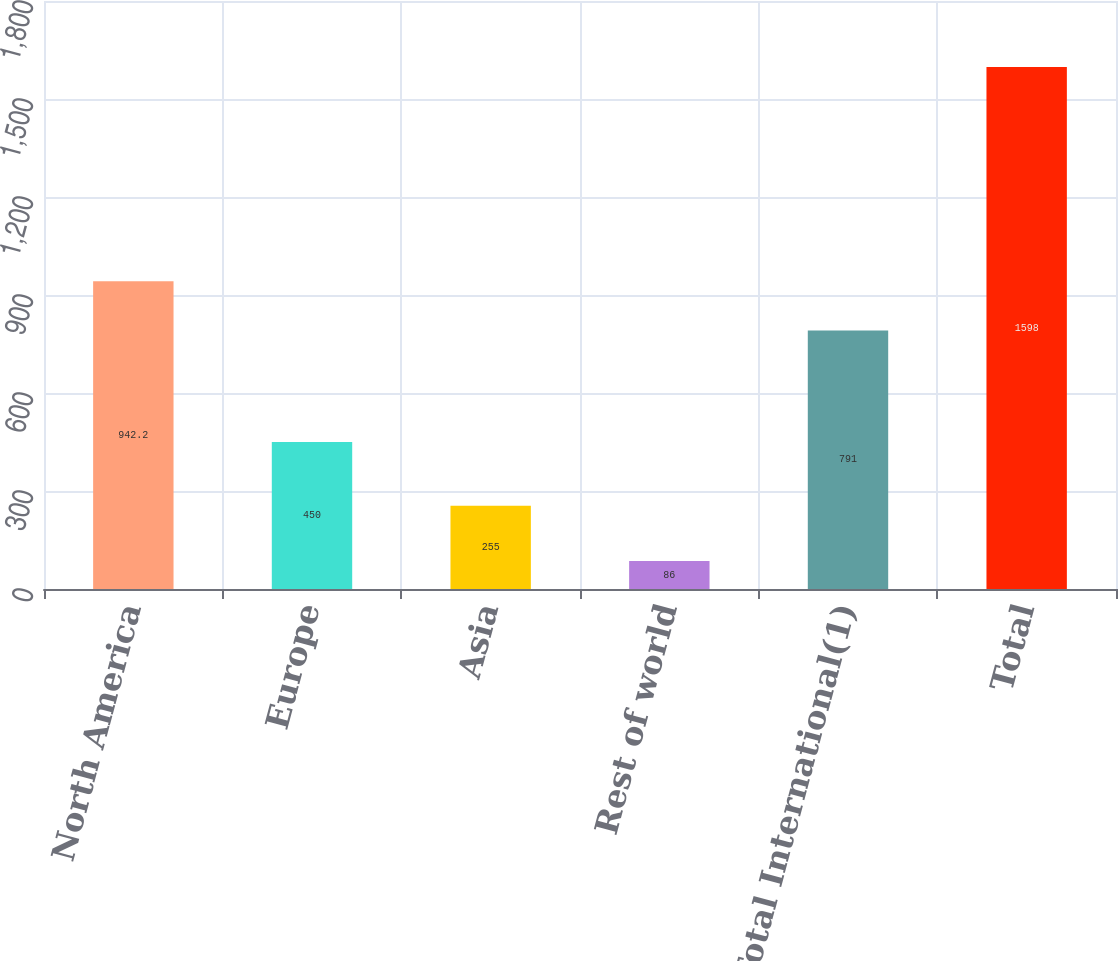Convert chart. <chart><loc_0><loc_0><loc_500><loc_500><bar_chart><fcel>North America<fcel>Europe<fcel>Asia<fcel>Rest of world<fcel>Total International(1)<fcel>Total<nl><fcel>942.2<fcel>450<fcel>255<fcel>86<fcel>791<fcel>1598<nl></chart> 